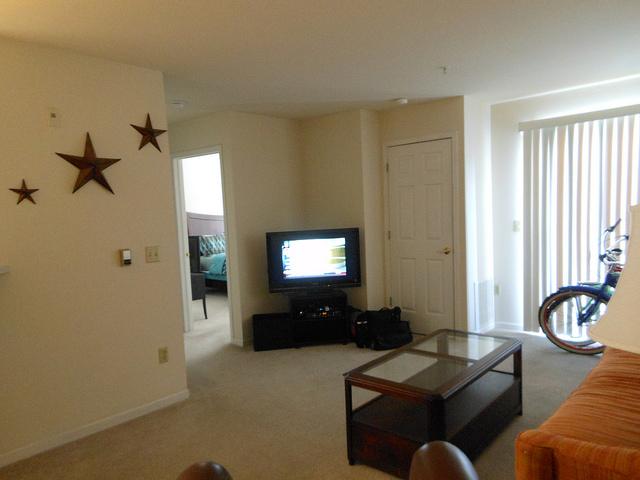How many stars are on the wall?
Keep it brief. 3. What holiday is depicted in this photo?
Give a very brief answer. None. Where is the remote control?
Be succinct. Couch. Why is the coffee table empty?
Give a very brief answer. Clean. What is next to the sliding glass doors?
Concise answer only. Bike. Are there people in the room?
Short answer required. No. Is there a fireplace?
Short answer required. No. Is the television on?
Be succinct. Yes. 